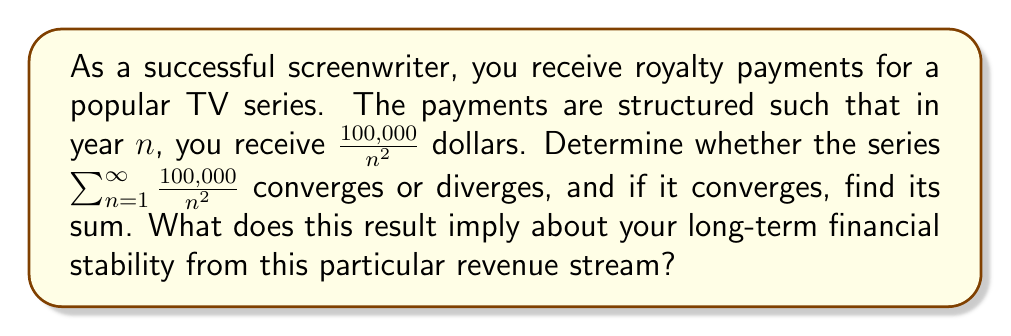Give your solution to this math problem. Let's approach this step-by-step:

1) First, we need to recognize the series. The general term of the series is $a_n = \frac{100,000}{n^2}$.

2) This is a p-series of the form $\sum_{n=1}^{\infty} \frac{k}{n^p}$, where $k = 100,000$ and $p = 2$.

3) We know that for a p-series:
   - If $p > 1$, the series converges
   - If $p \leq 1$, the series diverges

4) In this case, $p = 2 > 1$, so the series converges.

5) To find the sum, we can use the fact that for $\sum_{n=1}^{\infty} \frac{1}{n^2}$, the sum is known to be $\frac{\pi^2}{6}$.

6) Our series is $100,000$ times this sum. So:

   $$\sum_{n=1}^{\infty} \frac{100,000}{n^2} = 100,000 \cdot \sum_{n=1}^{\infty} \frac{1}{n^2} = 100,000 \cdot \frac{\pi^2}{6}$$

7) Calculating this:
   $$100,000 \cdot \frac{\pi^2}{6} \approx 164,493.41$$

This result implies that while the royalty payments will continue indefinitely, they will sum to a finite amount of approximately $164,493.41. This provides a measure of long-term financial stability, but the payments will decrease rapidly over time, so it's not a sustainable primary income source in the long run.
Answer: The series converges to $100,000 \cdot \frac{\pi^2}{6} \approx 164,493.41$ dollars. 